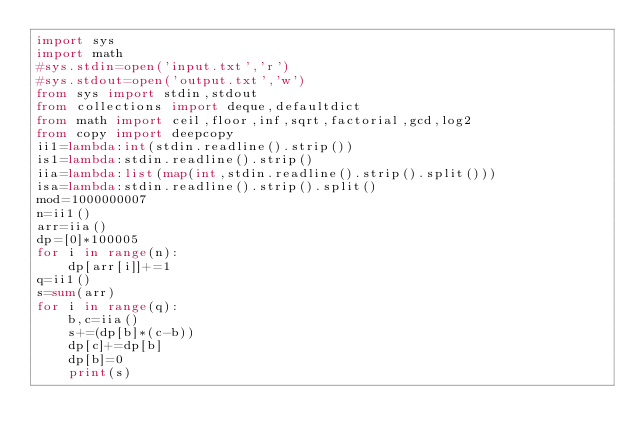<code> <loc_0><loc_0><loc_500><loc_500><_Python_>import sys
import math
#sys.stdin=open('input.txt','r')
#sys.stdout=open('output.txt','w')
from sys import stdin,stdout
from collections import deque,defaultdict
from math import ceil,floor,inf,sqrt,factorial,gcd,log2
from copy import deepcopy
ii1=lambda:int(stdin.readline().strip())
is1=lambda:stdin.readline().strip()
iia=lambda:list(map(int,stdin.readline().strip().split()))
isa=lambda:stdin.readline().strip().split()
mod=1000000007
n=ii1()
arr=iia()
dp=[0]*100005
for i in range(n):
    dp[arr[i]]+=1
q=ii1()
s=sum(arr)
for i in range(q):
    b,c=iia()
    s+=(dp[b]*(c-b))
    dp[c]+=dp[b]
    dp[b]=0
    print(s)


</code> 